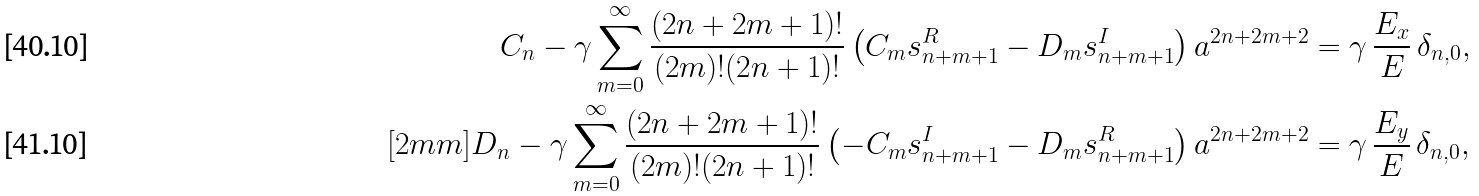Convert formula to latex. <formula><loc_0><loc_0><loc_500><loc_500>C _ { n } - \gamma \sum _ { m = 0 } ^ { \infty } \frac { ( 2 n + 2 m + 1 ) ! } { ( 2 m ) ! ( 2 n + 1 ) ! } \left ( C _ { m } s ^ { R } _ { n + m + 1 } - D _ { m } s ^ { I } _ { n + m + 1 } \right ) a ^ { 2 n + 2 m + 2 } & = \gamma \, \frac { E _ { x } } { E } \, \delta _ { n , 0 } , \\ [ 2 m m ] D _ { n } - \gamma \sum _ { m = 0 } ^ { \infty } \frac { ( 2 n + 2 m + 1 ) ! } { ( 2 m ) ! ( 2 n + 1 ) ! } \left ( - C _ { m } s ^ { I } _ { n + m + 1 } - D _ { m } s ^ { R } _ { n + m + 1 } \right ) a ^ { 2 n + 2 m + 2 } & = \gamma \, \frac { E _ { y } } { E } \, \delta _ { n , 0 } ,</formula> 